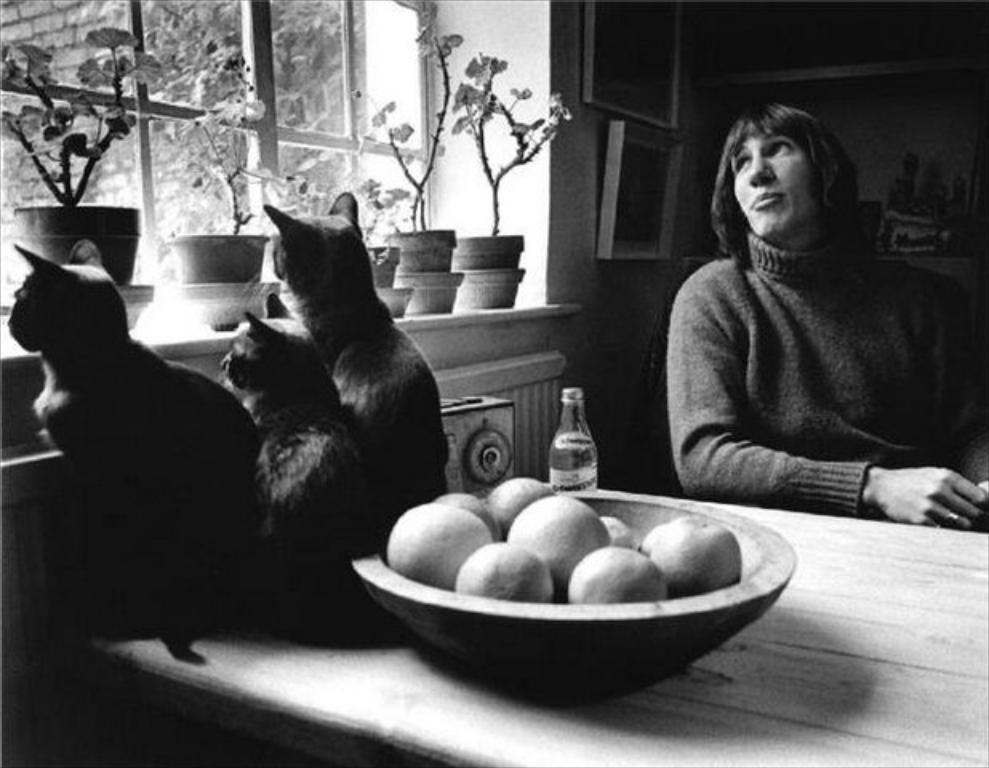Please provide a concise description of this image. Here we can see a woman sitting on the chair, and in front here is the table and fruits and cats and some more objects on it, and here are the flower pots ,and here is the window. 